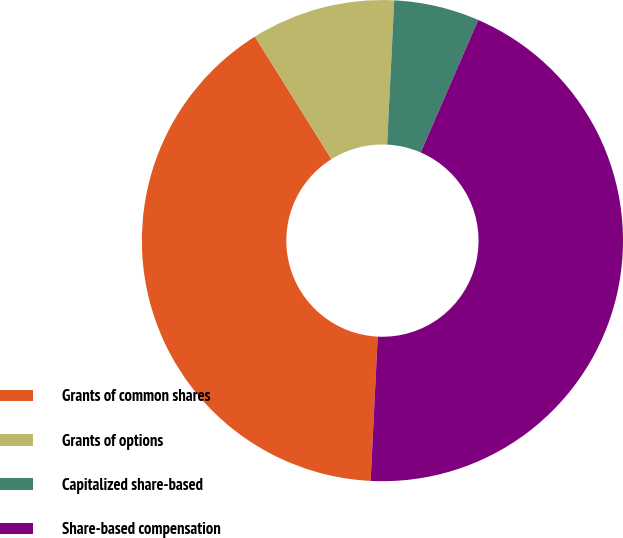<chart> <loc_0><loc_0><loc_500><loc_500><pie_chart><fcel>Grants of common shares<fcel>Grants of options<fcel>Capitalized share-based<fcel>Share-based compensation<nl><fcel>40.33%<fcel>9.67%<fcel>5.74%<fcel>44.26%<nl></chart> 